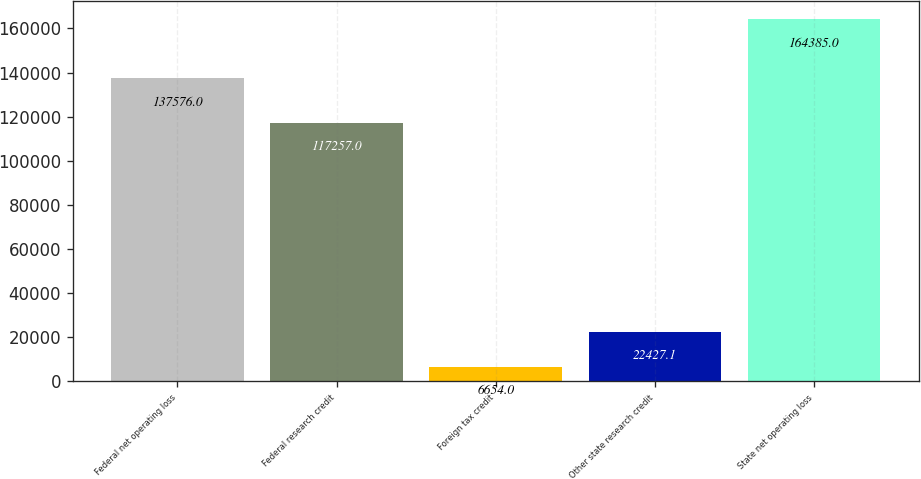<chart> <loc_0><loc_0><loc_500><loc_500><bar_chart><fcel>Federal net operating loss<fcel>Federal research credit<fcel>Foreign tax credit<fcel>Other state research credit<fcel>State net operating loss<nl><fcel>137576<fcel>117257<fcel>6654<fcel>22427.1<fcel>164385<nl></chart> 